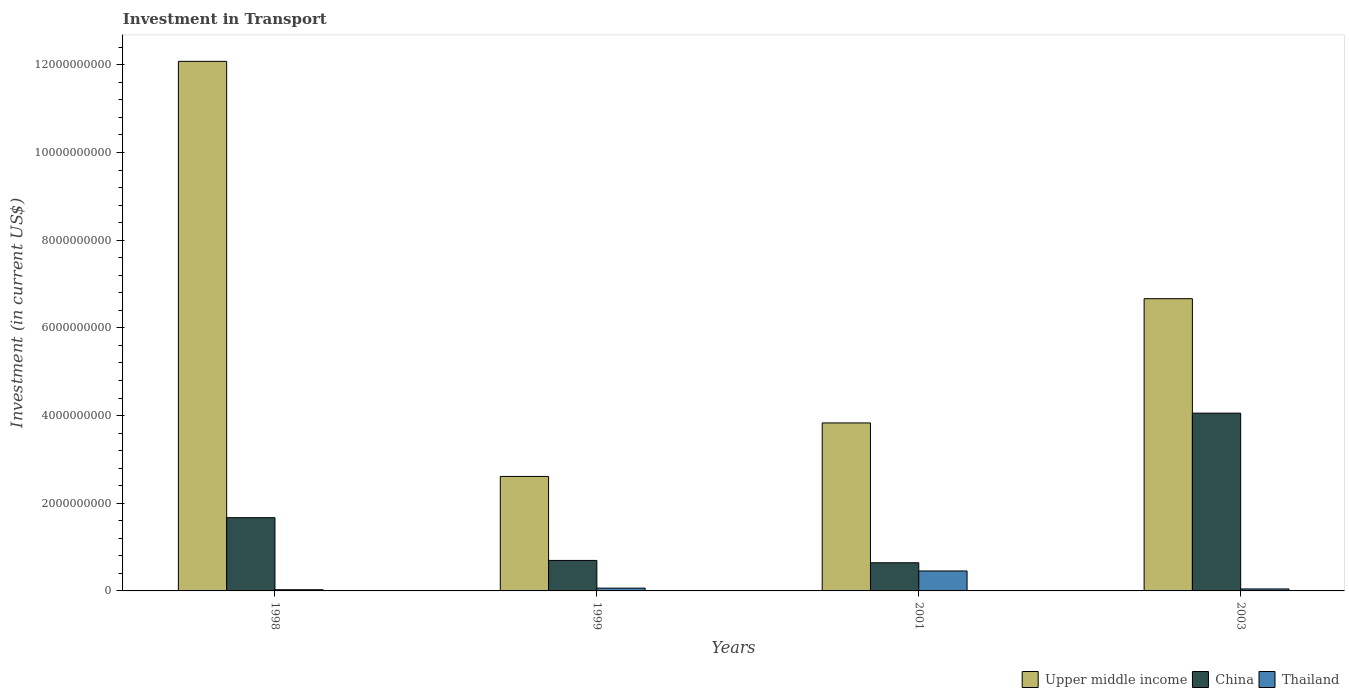How many bars are there on the 3rd tick from the left?
Your answer should be compact. 3. How many bars are there on the 1st tick from the right?
Keep it short and to the point. 3. In how many cases, is the number of bars for a given year not equal to the number of legend labels?
Offer a very short reply. 0. What is the amount invested in transport in Thailand in 1999?
Offer a very short reply. 6.37e+07. Across all years, what is the maximum amount invested in transport in Thailand?
Provide a short and direct response. 4.55e+08. Across all years, what is the minimum amount invested in transport in Thailand?
Give a very brief answer. 2.74e+07. In which year was the amount invested in transport in China minimum?
Provide a short and direct response. 2001. What is the total amount invested in transport in Thailand in the graph?
Provide a short and direct response. 5.91e+08. What is the difference between the amount invested in transport in Thailand in 1999 and that in 2003?
Your answer should be very brief. 1.87e+07. What is the difference between the amount invested in transport in Upper middle income in 1998 and the amount invested in transport in Thailand in 1999?
Ensure brevity in your answer.  1.20e+1. What is the average amount invested in transport in China per year?
Offer a terse response. 1.77e+09. In the year 2003, what is the difference between the amount invested in transport in China and amount invested in transport in Thailand?
Your response must be concise. 4.01e+09. What is the ratio of the amount invested in transport in Upper middle income in 1998 to that in 1999?
Your answer should be compact. 4.63. Is the difference between the amount invested in transport in China in 1998 and 2001 greater than the difference between the amount invested in transport in Thailand in 1998 and 2001?
Give a very brief answer. Yes. What is the difference between the highest and the second highest amount invested in transport in Thailand?
Provide a short and direct response. 3.91e+08. What is the difference between the highest and the lowest amount invested in transport in Upper middle income?
Offer a very short reply. 9.47e+09. In how many years, is the amount invested in transport in Thailand greater than the average amount invested in transport in Thailand taken over all years?
Offer a very short reply. 1. Is the sum of the amount invested in transport in China in 1999 and 2001 greater than the maximum amount invested in transport in Upper middle income across all years?
Your answer should be very brief. No. What does the 3rd bar from the left in 2001 represents?
Keep it short and to the point. Thailand. Are all the bars in the graph horizontal?
Your answer should be compact. No. How many years are there in the graph?
Ensure brevity in your answer.  4. Are the values on the major ticks of Y-axis written in scientific E-notation?
Offer a terse response. No. Does the graph contain grids?
Keep it short and to the point. No. How are the legend labels stacked?
Your answer should be very brief. Horizontal. What is the title of the graph?
Your answer should be compact. Investment in Transport. Does "Low & middle income" appear as one of the legend labels in the graph?
Offer a very short reply. No. What is the label or title of the Y-axis?
Your response must be concise. Investment (in current US$). What is the Investment (in current US$) in Upper middle income in 1998?
Provide a short and direct response. 1.21e+1. What is the Investment (in current US$) in China in 1998?
Give a very brief answer. 1.67e+09. What is the Investment (in current US$) in Thailand in 1998?
Give a very brief answer. 2.74e+07. What is the Investment (in current US$) in Upper middle income in 1999?
Ensure brevity in your answer.  2.61e+09. What is the Investment (in current US$) in China in 1999?
Keep it short and to the point. 6.96e+08. What is the Investment (in current US$) of Thailand in 1999?
Give a very brief answer. 6.37e+07. What is the Investment (in current US$) of Upper middle income in 2001?
Offer a very short reply. 3.83e+09. What is the Investment (in current US$) in China in 2001?
Offer a very short reply. 6.42e+08. What is the Investment (in current US$) in Thailand in 2001?
Provide a succinct answer. 4.55e+08. What is the Investment (in current US$) in Upper middle income in 2003?
Your answer should be compact. 6.67e+09. What is the Investment (in current US$) of China in 2003?
Provide a succinct answer. 4.05e+09. What is the Investment (in current US$) in Thailand in 2003?
Your answer should be compact. 4.50e+07. Across all years, what is the maximum Investment (in current US$) in Upper middle income?
Provide a succinct answer. 1.21e+1. Across all years, what is the maximum Investment (in current US$) of China?
Make the answer very short. 4.05e+09. Across all years, what is the maximum Investment (in current US$) of Thailand?
Offer a very short reply. 4.55e+08. Across all years, what is the minimum Investment (in current US$) of Upper middle income?
Make the answer very short. 2.61e+09. Across all years, what is the minimum Investment (in current US$) in China?
Make the answer very short. 6.42e+08. Across all years, what is the minimum Investment (in current US$) in Thailand?
Your answer should be compact. 2.74e+07. What is the total Investment (in current US$) of Upper middle income in the graph?
Give a very brief answer. 2.52e+1. What is the total Investment (in current US$) of China in the graph?
Your answer should be compact. 7.06e+09. What is the total Investment (in current US$) of Thailand in the graph?
Provide a succinct answer. 5.91e+08. What is the difference between the Investment (in current US$) in Upper middle income in 1998 and that in 1999?
Your answer should be compact. 9.47e+09. What is the difference between the Investment (in current US$) of China in 1998 and that in 1999?
Give a very brief answer. 9.75e+08. What is the difference between the Investment (in current US$) in Thailand in 1998 and that in 1999?
Offer a terse response. -3.63e+07. What is the difference between the Investment (in current US$) of Upper middle income in 1998 and that in 2001?
Make the answer very short. 8.25e+09. What is the difference between the Investment (in current US$) in China in 1998 and that in 2001?
Offer a terse response. 1.03e+09. What is the difference between the Investment (in current US$) in Thailand in 1998 and that in 2001?
Ensure brevity in your answer.  -4.28e+08. What is the difference between the Investment (in current US$) of Upper middle income in 1998 and that in 2003?
Make the answer very short. 5.41e+09. What is the difference between the Investment (in current US$) in China in 1998 and that in 2003?
Your response must be concise. -2.38e+09. What is the difference between the Investment (in current US$) in Thailand in 1998 and that in 2003?
Offer a very short reply. -1.76e+07. What is the difference between the Investment (in current US$) in Upper middle income in 1999 and that in 2001?
Provide a succinct answer. -1.22e+09. What is the difference between the Investment (in current US$) of China in 1999 and that in 2001?
Your answer should be compact. 5.33e+07. What is the difference between the Investment (in current US$) in Thailand in 1999 and that in 2001?
Your answer should be compact. -3.91e+08. What is the difference between the Investment (in current US$) in Upper middle income in 1999 and that in 2003?
Make the answer very short. -4.05e+09. What is the difference between the Investment (in current US$) of China in 1999 and that in 2003?
Your answer should be compact. -3.36e+09. What is the difference between the Investment (in current US$) of Thailand in 1999 and that in 2003?
Your answer should be compact. 1.87e+07. What is the difference between the Investment (in current US$) in Upper middle income in 2001 and that in 2003?
Provide a short and direct response. -2.83e+09. What is the difference between the Investment (in current US$) in China in 2001 and that in 2003?
Keep it short and to the point. -3.41e+09. What is the difference between the Investment (in current US$) in Thailand in 2001 and that in 2003?
Your answer should be compact. 4.10e+08. What is the difference between the Investment (in current US$) in Upper middle income in 1998 and the Investment (in current US$) in China in 1999?
Make the answer very short. 1.14e+1. What is the difference between the Investment (in current US$) in Upper middle income in 1998 and the Investment (in current US$) in Thailand in 1999?
Your response must be concise. 1.20e+1. What is the difference between the Investment (in current US$) in China in 1998 and the Investment (in current US$) in Thailand in 1999?
Offer a terse response. 1.61e+09. What is the difference between the Investment (in current US$) in Upper middle income in 1998 and the Investment (in current US$) in China in 2001?
Keep it short and to the point. 1.14e+1. What is the difference between the Investment (in current US$) in Upper middle income in 1998 and the Investment (in current US$) in Thailand in 2001?
Keep it short and to the point. 1.16e+1. What is the difference between the Investment (in current US$) in China in 1998 and the Investment (in current US$) in Thailand in 2001?
Offer a terse response. 1.22e+09. What is the difference between the Investment (in current US$) in Upper middle income in 1998 and the Investment (in current US$) in China in 2003?
Offer a very short reply. 8.02e+09. What is the difference between the Investment (in current US$) of Upper middle income in 1998 and the Investment (in current US$) of Thailand in 2003?
Provide a succinct answer. 1.20e+1. What is the difference between the Investment (in current US$) of China in 1998 and the Investment (in current US$) of Thailand in 2003?
Your answer should be compact. 1.63e+09. What is the difference between the Investment (in current US$) in Upper middle income in 1999 and the Investment (in current US$) in China in 2001?
Offer a very short reply. 1.97e+09. What is the difference between the Investment (in current US$) of Upper middle income in 1999 and the Investment (in current US$) of Thailand in 2001?
Keep it short and to the point. 2.16e+09. What is the difference between the Investment (in current US$) of China in 1999 and the Investment (in current US$) of Thailand in 2001?
Your response must be concise. 2.41e+08. What is the difference between the Investment (in current US$) of Upper middle income in 1999 and the Investment (in current US$) of China in 2003?
Make the answer very short. -1.44e+09. What is the difference between the Investment (in current US$) in Upper middle income in 1999 and the Investment (in current US$) in Thailand in 2003?
Provide a succinct answer. 2.57e+09. What is the difference between the Investment (in current US$) of China in 1999 and the Investment (in current US$) of Thailand in 2003?
Make the answer very short. 6.51e+08. What is the difference between the Investment (in current US$) of Upper middle income in 2001 and the Investment (in current US$) of China in 2003?
Give a very brief answer. -2.23e+08. What is the difference between the Investment (in current US$) of Upper middle income in 2001 and the Investment (in current US$) of Thailand in 2003?
Ensure brevity in your answer.  3.79e+09. What is the difference between the Investment (in current US$) of China in 2001 and the Investment (in current US$) of Thailand in 2003?
Your response must be concise. 5.97e+08. What is the average Investment (in current US$) of Upper middle income per year?
Offer a very short reply. 6.30e+09. What is the average Investment (in current US$) in China per year?
Ensure brevity in your answer.  1.77e+09. What is the average Investment (in current US$) of Thailand per year?
Give a very brief answer. 1.48e+08. In the year 1998, what is the difference between the Investment (in current US$) of Upper middle income and Investment (in current US$) of China?
Keep it short and to the point. 1.04e+1. In the year 1998, what is the difference between the Investment (in current US$) of Upper middle income and Investment (in current US$) of Thailand?
Offer a terse response. 1.21e+1. In the year 1998, what is the difference between the Investment (in current US$) in China and Investment (in current US$) in Thailand?
Your response must be concise. 1.64e+09. In the year 1999, what is the difference between the Investment (in current US$) of Upper middle income and Investment (in current US$) of China?
Provide a succinct answer. 1.92e+09. In the year 1999, what is the difference between the Investment (in current US$) in Upper middle income and Investment (in current US$) in Thailand?
Your answer should be compact. 2.55e+09. In the year 1999, what is the difference between the Investment (in current US$) of China and Investment (in current US$) of Thailand?
Give a very brief answer. 6.32e+08. In the year 2001, what is the difference between the Investment (in current US$) in Upper middle income and Investment (in current US$) in China?
Offer a terse response. 3.19e+09. In the year 2001, what is the difference between the Investment (in current US$) in Upper middle income and Investment (in current US$) in Thailand?
Your response must be concise. 3.38e+09. In the year 2001, what is the difference between the Investment (in current US$) of China and Investment (in current US$) of Thailand?
Provide a succinct answer. 1.87e+08. In the year 2003, what is the difference between the Investment (in current US$) of Upper middle income and Investment (in current US$) of China?
Your answer should be compact. 2.61e+09. In the year 2003, what is the difference between the Investment (in current US$) of Upper middle income and Investment (in current US$) of Thailand?
Offer a terse response. 6.62e+09. In the year 2003, what is the difference between the Investment (in current US$) of China and Investment (in current US$) of Thailand?
Offer a terse response. 4.01e+09. What is the ratio of the Investment (in current US$) in Upper middle income in 1998 to that in 1999?
Provide a short and direct response. 4.63. What is the ratio of the Investment (in current US$) of China in 1998 to that in 1999?
Provide a succinct answer. 2.4. What is the ratio of the Investment (in current US$) of Thailand in 1998 to that in 1999?
Offer a terse response. 0.43. What is the ratio of the Investment (in current US$) in Upper middle income in 1998 to that in 2001?
Provide a succinct answer. 3.15. What is the ratio of the Investment (in current US$) of China in 1998 to that in 2001?
Make the answer very short. 2.6. What is the ratio of the Investment (in current US$) of Thailand in 1998 to that in 2001?
Provide a short and direct response. 0.06. What is the ratio of the Investment (in current US$) in Upper middle income in 1998 to that in 2003?
Your answer should be very brief. 1.81. What is the ratio of the Investment (in current US$) in China in 1998 to that in 2003?
Your answer should be compact. 0.41. What is the ratio of the Investment (in current US$) in Thailand in 1998 to that in 2003?
Provide a short and direct response. 0.61. What is the ratio of the Investment (in current US$) in Upper middle income in 1999 to that in 2001?
Keep it short and to the point. 0.68. What is the ratio of the Investment (in current US$) in China in 1999 to that in 2001?
Make the answer very short. 1.08. What is the ratio of the Investment (in current US$) in Thailand in 1999 to that in 2001?
Your response must be concise. 0.14. What is the ratio of the Investment (in current US$) in Upper middle income in 1999 to that in 2003?
Your answer should be compact. 0.39. What is the ratio of the Investment (in current US$) of China in 1999 to that in 2003?
Provide a succinct answer. 0.17. What is the ratio of the Investment (in current US$) of Thailand in 1999 to that in 2003?
Give a very brief answer. 1.42. What is the ratio of the Investment (in current US$) of Upper middle income in 2001 to that in 2003?
Offer a terse response. 0.57. What is the ratio of the Investment (in current US$) in China in 2001 to that in 2003?
Offer a very short reply. 0.16. What is the ratio of the Investment (in current US$) of Thailand in 2001 to that in 2003?
Ensure brevity in your answer.  10.11. What is the difference between the highest and the second highest Investment (in current US$) of Upper middle income?
Your answer should be very brief. 5.41e+09. What is the difference between the highest and the second highest Investment (in current US$) of China?
Your answer should be very brief. 2.38e+09. What is the difference between the highest and the second highest Investment (in current US$) of Thailand?
Ensure brevity in your answer.  3.91e+08. What is the difference between the highest and the lowest Investment (in current US$) in Upper middle income?
Offer a terse response. 9.47e+09. What is the difference between the highest and the lowest Investment (in current US$) in China?
Keep it short and to the point. 3.41e+09. What is the difference between the highest and the lowest Investment (in current US$) of Thailand?
Your response must be concise. 4.28e+08. 